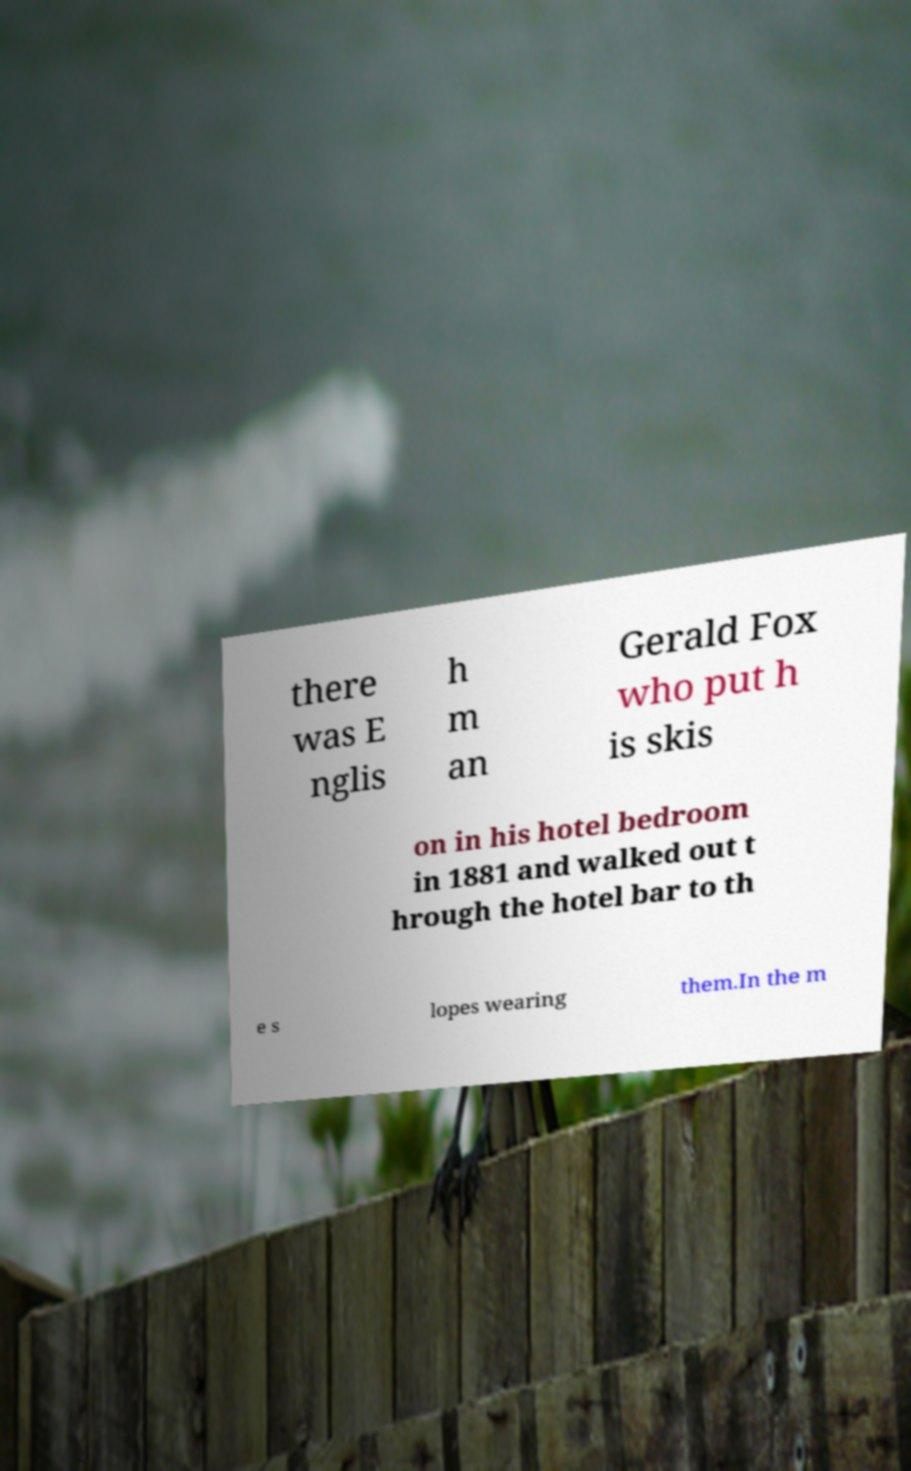Can you read and provide the text displayed in the image?This photo seems to have some interesting text. Can you extract and type it out for me? there was E nglis h m an Gerald Fox who put h is skis on in his hotel bedroom in 1881 and walked out t hrough the hotel bar to th e s lopes wearing them.In the m 